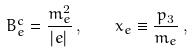<formula> <loc_0><loc_0><loc_500><loc_500>B _ { e } ^ { c } = \frac { m _ { e } ^ { 2 } } { | e | } \, , \quad x _ { e } \equiv \frac { p _ { 3 } } { m _ { e } } \, ,</formula> 